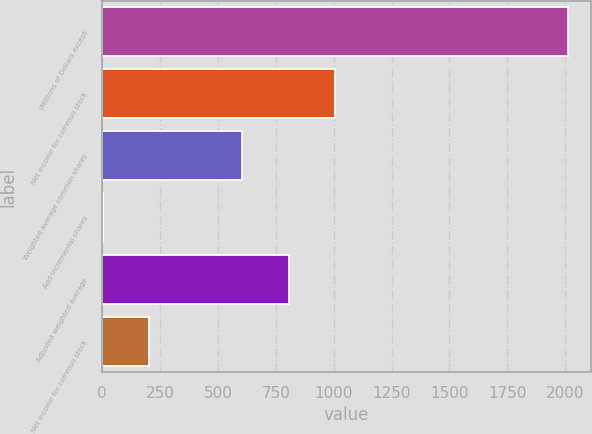<chart> <loc_0><loc_0><loc_500><loc_500><bar_chart><fcel>(Millions of Dollars except<fcel>Net income for common stock<fcel>Weighted average common shares<fcel>Add Incremental shares<fcel>Adjusted weighted average<fcel>Net Income for common stock<nl><fcel>2010<fcel>1005.8<fcel>604.12<fcel>1.6<fcel>804.96<fcel>202.44<nl></chart> 